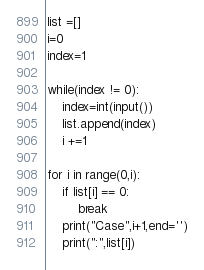<code> <loc_0><loc_0><loc_500><loc_500><_Python_>list =[]
i=0
index=1

while(index != 0):
    index=int(input())
    list.append(index)
    i +=1

for i in range(0,i):
    if list[i] == 0:
        break
    print("Case",i+1,end='')
    print(":",list[i])
</code> 